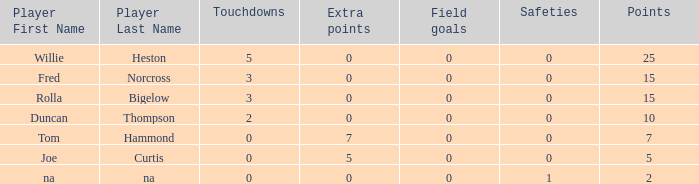How many Touchdowns have a Player of rolla bigelow, and an Extra points smaller than 0? None. 